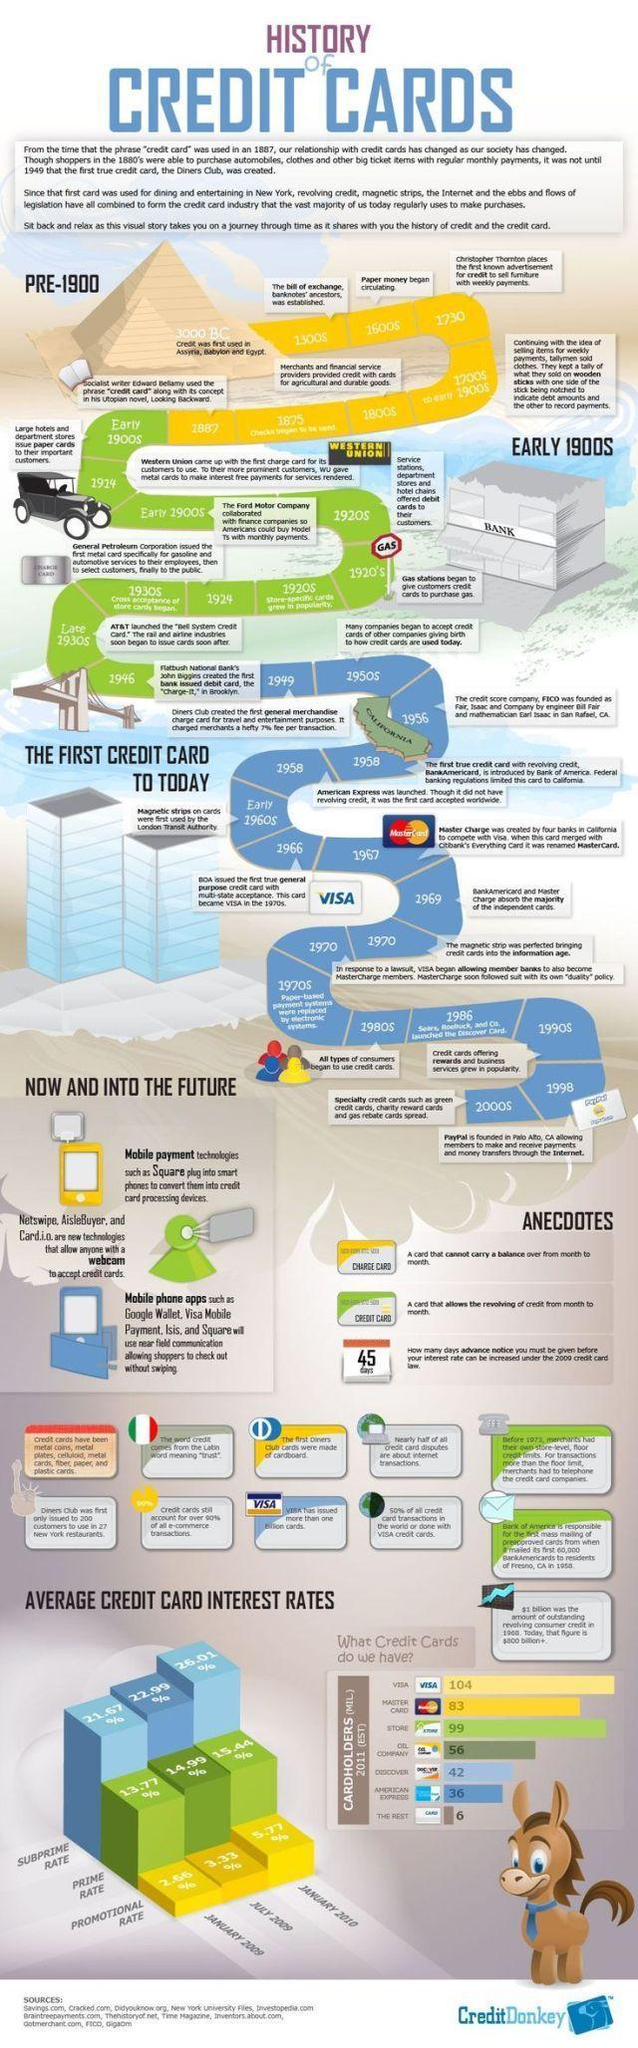Which credit card is used by most?
Answer the question with a short phrase. VISA What was the promotional rate of credit cards as of January 2010? 5.77% What was the prime rate of credit cards in January 2009? 13.77% What was the subprime rate of credit card in July 2009? 22.99% 